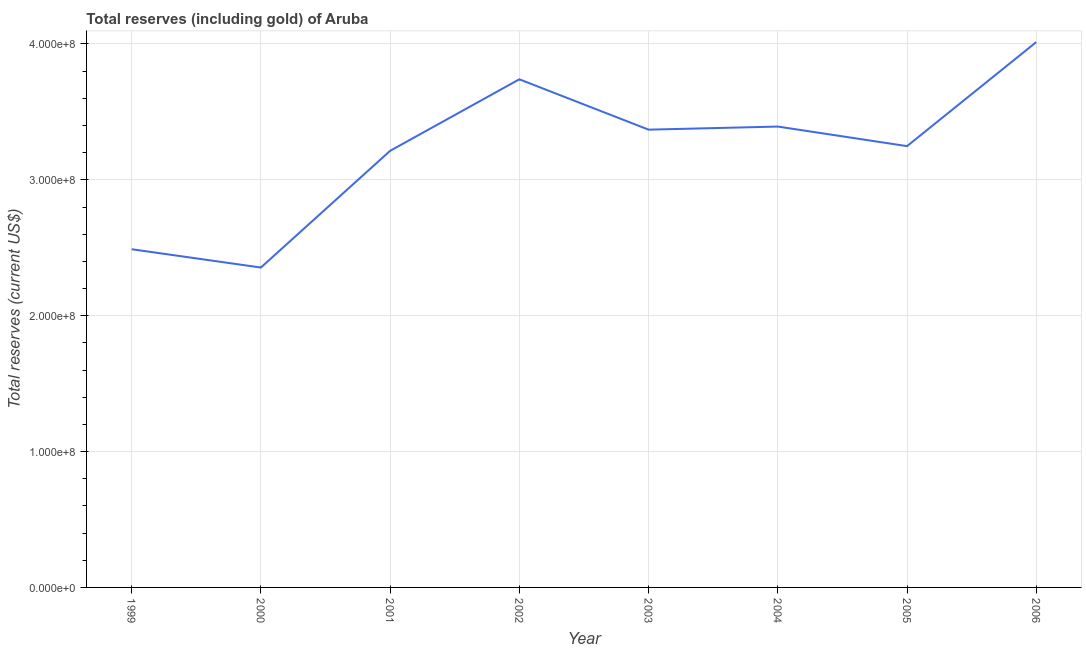What is the total reserves (including gold) in 2000?
Make the answer very short. 2.35e+08. Across all years, what is the maximum total reserves (including gold)?
Ensure brevity in your answer.  4.01e+08. Across all years, what is the minimum total reserves (including gold)?
Offer a terse response. 2.35e+08. In which year was the total reserves (including gold) maximum?
Make the answer very short. 2006. What is the sum of the total reserves (including gold)?
Ensure brevity in your answer.  2.58e+09. What is the difference between the total reserves (including gold) in 2003 and 2006?
Provide a short and direct response. -6.44e+07. What is the average total reserves (including gold) per year?
Offer a very short reply. 3.23e+08. What is the median total reserves (including gold)?
Offer a terse response. 3.31e+08. What is the ratio of the total reserves (including gold) in 2000 to that in 2003?
Provide a succinct answer. 0.7. Is the difference between the total reserves (including gold) in 2002 and 2003 greater than the difference between any two years?
Offer a very short reply. No. What is the difference between the highest and the second highest total reserves (including gold)?
Give a very brief answer. 2.74e+07. Is the sum of the total reserves (including gold) in 2000 and 2003 greater than the maximum total reserves (including gold) across all years?
Give a very brief answer. Yes. What is the difference between the highest and the lowest total reserves (including gold)?
Your response must be concise. 1.66e+08. What is the difference between two consecutive major ticks on the Y-axis?
Your response must be concise. 1.00e+08. Are the values on the major ticks of Y-axis written in scientific E-notation?
Your answer should be compact. Yes. What is the title of the graph?
Your answer should be compact. Total reserves (including gold) of Aruba. What is the label or title of the X-axis?
Give a very brief answer. Year. What is the label or title of the Y-axis?
Make the answer very short. Total reserves (current US$). What is the Total reserves (current US$) of 1999?
Offer a terse response. 2.49e+08. What is the Total reserves (current US$) in 2000?
Your response must be concise. 2.35e+08. What is the Total reserves (current US$) of 2001?
Provide a short and direct response. 3.21e+08. What is the Total reserves (current US$) of 2002?
Your answer should be very brief. 3.74e+08. What is the Total reserves (current US$) of 2003?
Keep it short and to the point. 3.37e+08. What is the Total reserves (current US$) in 2004?
Provide a short and direct response. 3.39e+08. What is the Total reserves (current US$) in 2005?
Your answer should be compact. 3.25e+08. What is the Total reserves (current US$) of 2006?
Your answer should be very brief. 4.01e+08. What is the difference between the Total reserves (current US$) in 1999 and 2000?
Ensure brevity in your answer.  1.35e+07. What is the difference between the Total reserves (current US$) in 1999 and 2001?
Provide a short and direct response. -7.24e+07. What is the difference between the Total reserves (current US$) in 1999 and 2002?
Provide a succinct answer. -1.25e+08. What is the difference between the Total reserves (current US$) in 1999 and 2003?
Your answer should be very brief. -8.80e+07. What is the difference between the Total reserves (current US$) in 1999 and 2004?
Keep it short and to the point. -9.03e+07. What is the difference between the Total reserves (current US$) in 1999 and 2005?
Your answer should be very brief. -7.59e+07. What is the difference between the Total reserves (current US$) in 1999 and 2006?
Your answer should be compact. -1.52e+08. What is the difference between the Total reserves (current US$) in 2000 and 2001?
Your answer should be very brief. -8.59e+07. What is the difference between the Total reserves (current US$) in 2000 and 2002?
Your answer should be very brief. -1.39e+08. What is the difference between the Total reserves (current US$) in 2000 and 2003?
Your answer should be compact. -1.01e+08. What is the difference between the Total reserves (current US$) in 2000 and 2004?
Keep it short and to the point. -1.04e+08. What is the difference between the Total reserves (current US$) in 2000 and 2005?
Offer a terse response. -8.94e+07. What is the difference between the Total reserves (current US$) in 2000 and 2006?
Ensure brevity in your answer.  -1.66e+08. What is the difference between the Total reserves (current US$) in 2001 and 2002?
Provide a succinct answer. -5.26e+07. What is the difference between the Total reserves (current US$) in 2001 and 2003?
Provide a short and direct response. -1.56e+07. What is the difference between the Total reserves (current US$) in 2001 and 2004?
Give a very brief answer. -1.79e+07. What is the difference between the Total reserves (current US$) in 2001 and 2005?
Keep it short and to the point. -3.45e+06. What is the difference between the Total reserves (current US$) in 2001 and 2006?
Keep it short and to the point. -8.00e+07. What is the difference between the Total reserves (current US$) in 2002 and 2003?
Your response must be concise. 3.71e+07. What is the difference between the Total reserves (current US$) in 2002 and 2004?
Give a very brief answer. 3.48e+07. What is the difference between the Total reserves (current US$) in 2002 and 2005?
Your answer should be very brief. 4.92e+07. What is the difference between the Total reserves (current US$) in 2002 and 2006?
Offer a very short reply. -2.74e+07. What is the difference between the Total reserves (current US$) in 2003 and 2004?
Provide a succinct answer. -2.28e+06. What is the difference between the Total reserves (current US$) in 2003 and 2005?
Your answer should be compact. 1.21e+07. What is the difference between the Total reserves (current US$) in 2003 and 2006?
Ensure brevity in your answer.  -6.44e+07. What is the difference between the Total reserves (current US$) in 2004 and 2005?
Offer a very short reply. 1.44e+07. What is the difference between the Total reserves (current US$) in 2004 and 2006?
Your response must be concise. -6.22e+07. What is the difference between the Total reserves (current US$) in 2005 and 2006?
Your response must be concise. -7.66e+07. What is the ratio of the Total reserves (current US$) in 1999 to that in 2000?
Your answer should be compact. 1.06. What is the ratio of the Total reserves (current US$) in 1999 to that in 2001?
Keep it short and to the point. 0.78. What is the ratio of the Total reserves (current US$) in 1999 to that in 2002?
Offer a very short reply. 0.67. What is the ratio of the Total reserves (current US$) in 1999 to that in 2003?
Offer a terse response. 0.74. What is the ratio of the Total reserves (current US$) in 1999 to that in 2004?
Keep it short and to the point. 0.73. What is the ratio of the Total reserves (current US$) in 1999 to that in 2005?
Keep it short and to the point. 0.77. What is the ratio of the Total reserves (current US$) in 1999 to that in 2006?
Ensure brevity in your answer.  0.62. What is the ratio of the Total reserves (current US$) in 2000 to that in 2001?
Make the answer very short. 0.73. What is the ratio of the Total reserves (current US$) in 2000 to that in 2002?
Keep it short and to the point. 0.63. What is the ratio of the Total reserves (current US$) in 2000 to that in 2003?
Your response must be concise. 0.7. What is the ratio of the Total reserves (current US$) in 2000 to that in 2004?
Provide a short and direct response. 0.69. What is the ratio of the Total reserves (current US$) in 2000 to that in 2005?
Your response must be concise. 0.72. What is the ratio of the Total reserves (current US$) in 2000 to that in 2006?
Ensure brevity in your answer.  0.59. What is the ratio of the Total reserves (current US$) in 2001 to that in 2002?
Provide a short and direct response. 0.86. What is the ratio of the Total reserves (current US$) in 2001 to that in 2003?
Your response must be concise. 0.95. What is the ratio of the Total reserves (current US$) in 2001 to that in 2004?
Keep it short and to the point. 0.95. What is the ratio of the Total reserves (current US$) in 2001 to that in 2006?
Your answer should be very brief. 0.8. What is the ratio of the Total reserves (current US$) in 2002 to that in 2003?
Keep it short and to the point. 1.11. What is the ratio of the Total reserves (current US$) in 2002 to that in 2004?
Offer a terse response. 1.1. What is the ratio of the Total reserves (current US$) in 2002 to that in 2005?
Give a very brief answer. 1.15. What is the ratio of the Total reserves (current US$) in 2002 to that in 2006?
Your answer should be compact. 0.93. What is the ratio of the Total reserves (current US$) in 2003 to that in 2006?
Your answer should be compact. 0.84. What is the ratio of the Total reserves (current US$) in 2004 to that in 2005?
Offer a very short reply. 1.04. What is the ratio of the Total reserves (current US$) in 2004 to that in 2006?
Offer a very short reply. 0.84. What is the ratio of the Total reserves (current US$) in 2005 to that in 2006?
Provide a short and direct response. 0.81. 